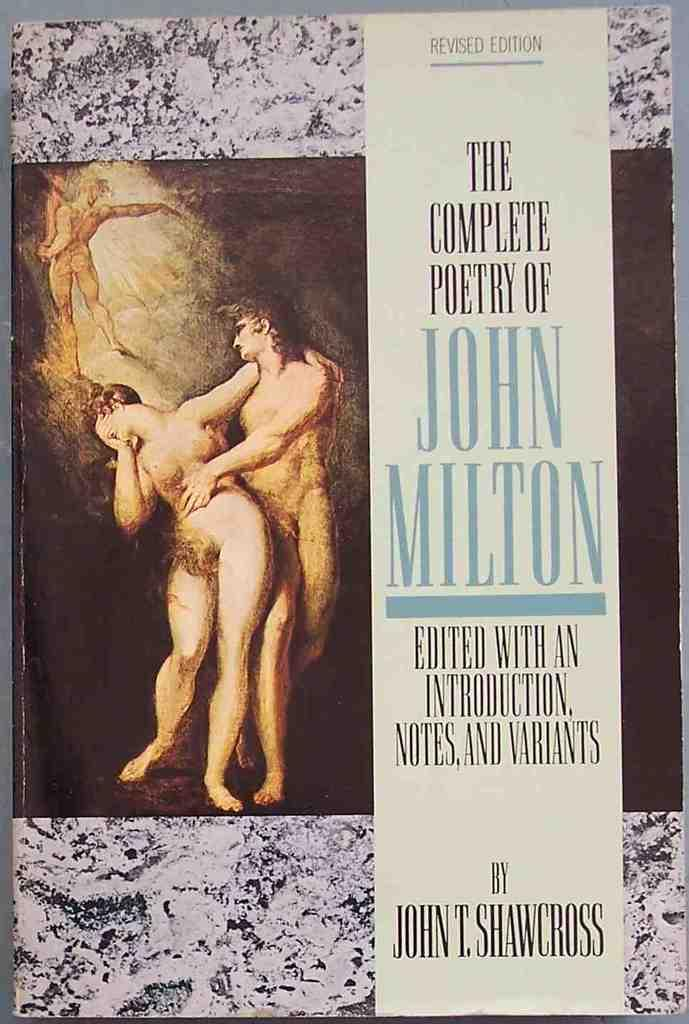What is featured in the image? There is a poster in the image. What is shown on the poster? There are people depicted on the poster. What else can be seen on the poster besides the people? There is text present on the poster. What type of hydrant is present in the image? There is no hydrant present in the image; it only features a poster with people and text. What type of berry is being held by the people on the poster? There is no berry present in the image, as it only features a poster with people and text. 